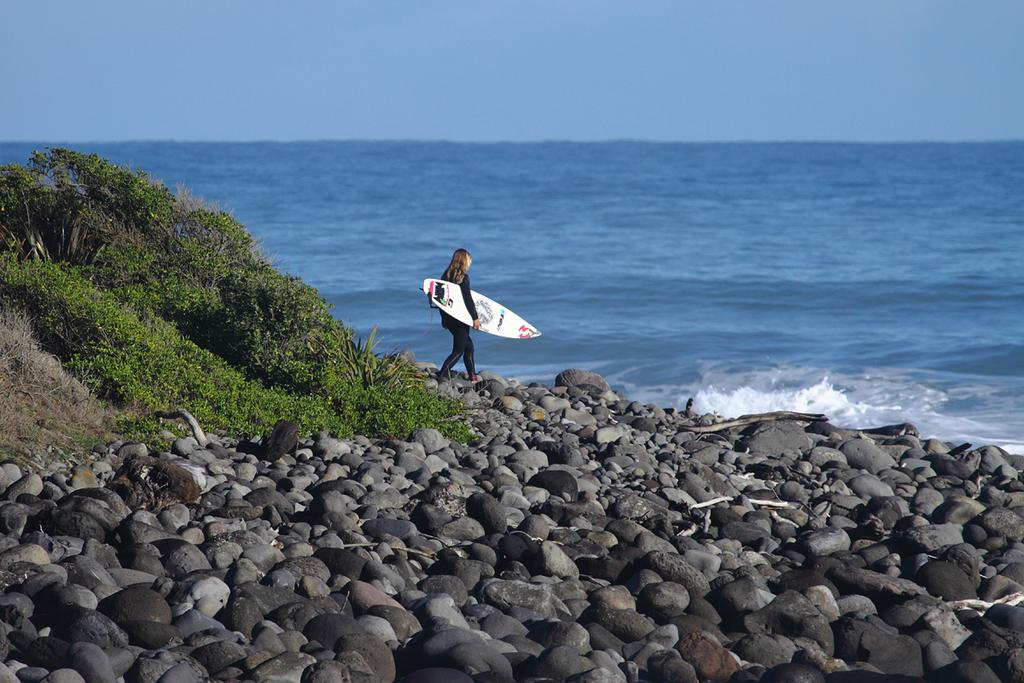What is the primary element visible in the image? There is water in the image. What can be seen near the water? There are trees and stones near the water. What is the woman in the image carrying? The woman is carrying a surfboard. What is visible in the background of the image? The sky is visible in the image. What type of control system is being used to navigate the hole in the image? There is no hole or control system present in the image. 